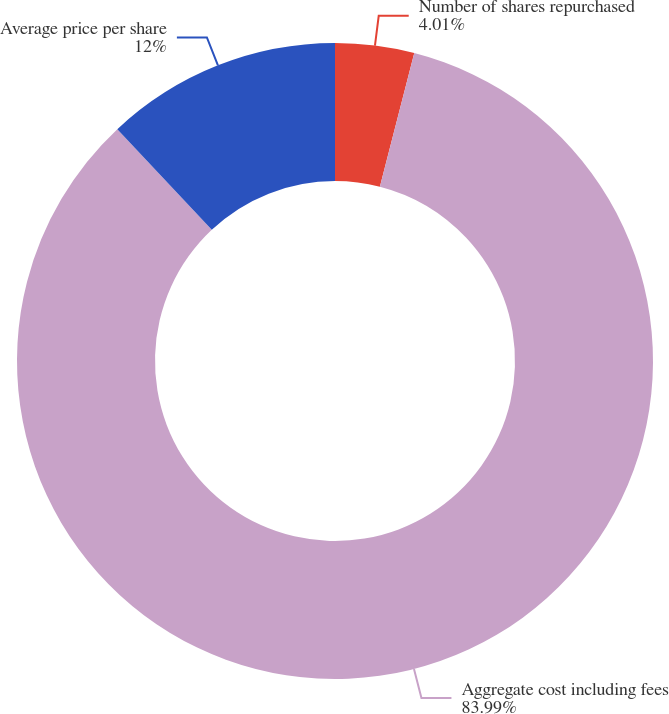Convert chart. <chart><loc_0><loc_0><loc_500><loc_500><pie_chart><fcel>Number of shares repurchased<fcel>Aggregate cost including fees<fcel>Average price per share<nl><fcel>4.01%<fcel>83.99%<fcel>12.0%<nl></chart> 